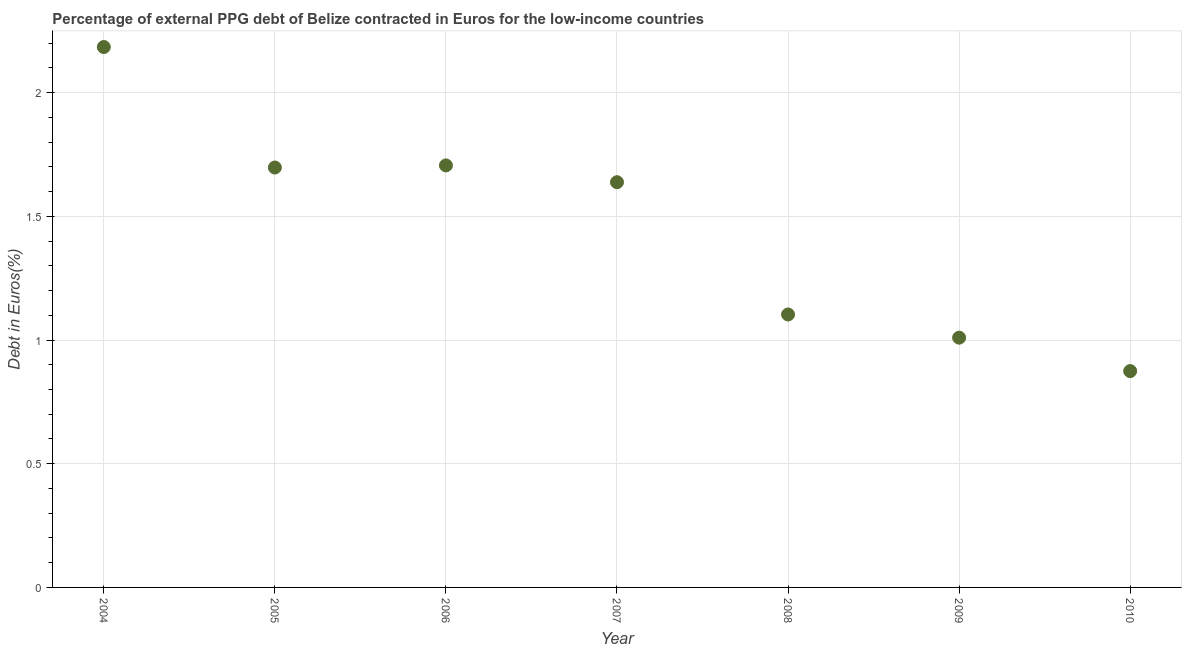What is the currency composition of ppg debt in 2009?
Give a very brief answer. 1.01. Across all years, what is the maximum currency composition of ppg debt?
Offer a very short reply. 2.18. Across all years, what is the minimum currency composition of ppg debt?
Provide a succinct answer. 0.87. What is the sum of the currency composition of ppg debt?
Make the answer very short. 10.21. What is the difference between the currency composition of ppg debt in 2004 and 2005?
Offer a very short reply. 0.49. What is the average currency composition of ppg debt per year?
Keep it short and to the point. 1.46. What is the median currency composition of ppg debt?
Offer a terse response. 1.64. In how many years, is the currency composition of ppg debt greater than 0.4 %?
Offer a terse response. 7. What is the ratio of the currency composition of ppg debt in 2006 to that in 2009?
Provide a short and direct response. 1.69. Is the difference between the currency composition of ppg debt in 2009 and 2010 greater than the difference between any two years?
Your response must be concise. No. What is the difference between the highest and the second highest currency composition of ppg debt?
Ensure brevity in your answer.  0.48. Is the sum of the currency composition of ppg debt in 2009 and 2010 greater than the maximum currency composition of ppg debt across all years?
Give a very brief answer. No. What is the difference between the highest and the lowest currency composition of ppg debt?
Offer a terse response. 1.31. In how many years, is the currency composition of ppg debt greater than the average currency composition of ppg debt taken over all years?
Offer a terse response. 4. How many years are there in the graph?
Your response must be concise. 7. What is the difference between two consecutive major ticks on the Y-axis?
Ensure brevity in your answer.  0.5. Are the values on the major ticks of Y-axis written in scientific E-notation?
Provide a short and direct response. No. Does the graph contain grids?
Your response must be concise. Yes. What is the title of the graph?
Keep it short and to the point. Percentage of external PPG debt of Belize contracted in Euros for the low-income countries. What is the label or title of the X-axis?
Keep it short and to the point. Year. What is the label or title of the Y-axis?
Make the answer very short. Debt in Euros(%). What is the Debt in Euros(%) in 2004?
Make the answer very short. 2.18. What is the Debt in Euros(%) in 2005?
Offer a very short reply. 1.7. What is the Debt in Euros(%) in 2006?
Ensure brevity in your answer.  1.71. What is the Debt in Euros(%) in 2007?
Ensure brevity in your answer.  1.64. What is the Debt in Euros(%) in 2008?
Keep it short and to the point. 1.1. What is the Debt in Euros(%) in 2009?
Offer a very short reply. 1.01. What is the Debt in Euros(%) in 2010?
Offer a very short reply. 0.87. What is the difference between the Debt in Euros(%) in 2004 and 2005?
Provide a short and direct response. 0.49. What is the difference between the Debt in Euros(%) in 2004 and 2006?
Offer a terse response. 0.48. What is the difference between the Debt in Euros(%) in 2004 and 2007?
Offer a very short reply. 0.55. What is the difference between the Debt in Euros(%) in 2004 and 2008?
Offer a very short reply. 1.08. What is the difference between the Debt in Euros(%) in 2004 and 2009?
Your answer should be compact. 1.17. What is the difference between the Debt in Euros(%) in 2004 and 2010?
Your response must be concise. 1.31. What is the difference between the Debt in Euros(%) in 2005 and 2006?
Keep it short and to the point. -0.01. What is the difference between the Debt in Euros(%) in 2005 and 2007?
Provide a succinct answer. 0.06. What is the difference between the Debt in Euros(%) in 2005 and 2008?
Ensure brevity in your answer.  0.59. What is the difference between the Debt in Euros(%) in 2005 and 2009?
Offer a terse response. 0.69. What is the difference between the Debt in Euros(%) in 2005 and 2010?
Your answer should be compact. 0.82. What is the difference between the Debt in Euros(%) in 2006 and 2007?
Your response must be concise. 0.07. What is the difference between the Debt in Euros(%) in 2006 and 2008?
Provide a succinct answer. 0.6. What is the difference between the Debt in Euros(%) in 2006 and 2009?
Keep it short and to the point. 0.7. What is the difference between the Debt in Euros(%) in 2006 and 2010?
Ensure brevity in your answer.  0.83. What is the difference between the Debt in Euros(%) in 2007 and 2008?
Your response must be concise. 0.53. What is the difference between the Debt in Euros(%) in 2007 and 2009?
Provide a succinct answer. 0.63. What is the difference between the Debt in Euros(%) in 2007 and 2010?
Give a very brief answer. 0.76. What is the difference between the Debt in Euros(%) in 2008 and 2009?
Offer a very short reply. 0.09. What is the difference between the Debt in Euros(%) in 2008 and 2010?
Ensure brevity in your answer.  0.23. What is the difference between the Debt in Euros(%) in 2009 and 2010?
Ensure brevity in your answer.  0.14. What is the ratio of the Debt in Euros(%) in 2004 to that in 2005?
Your answer should be very brief. 1.29. What is the ratio of the Debt in Euros(%) in 2004 to that in 2006?
Keep it short and to the point. 1.28. What is the ratio of the Debt in Euros(%) in 2004 to that in 2007?
Provide a short and direct response. 1.33. What is the ratio of the Debt in Euros(%) in 2004 to that in 2008?
Offer a terse response. 1.98. What is the ratio of the Debt in Euros(%) in 2004 to that in 2009?
Your answer should be compact. 2.16. What is the ratio of the Debt in Euros(%) in 2004 to that in 2010?
Offer a very short reply. 2.5. What is the ratio of the Debt in Euros(%) in 2005 to that in 2006?
Your response must be concise. 0.99. What is the ratio of the Debt in Euros(%) in 2005 to that in 2007?
Make the answer very short. 1.04. What is the ratio of the Debt in Euros(%) in 2005 to that in 2008?
Ensure brevity in your answer.  1.54. What is the ratio of the Debt in Euros(%) in 2005 to that in 2009?
Give a very brief answer. 1.68. What is the ratio of the Debt in Euros(%) in 2005 to that in 2010?
Give a very brief answer. 1.94. What is the ratio of the Debt in Euros(%) in 2006 to that in 2007?
Provide a short and direct response. 1.04. What is the ratio of the Debt in Euros(%) in 2006 to that in 2008?
Give a very brief answer. 1.55. What is the ratio of the Debt in Euros(%) in 2006 to that in 2009?
Your answer should be compact. 1.69. What is the ratio of the Debt in Euros(%) in 2006 to that in 2010?
Give a very brief answer. 1.95. What is the ratio of the Debt in Euros(%) in 2007 to that in 2008?
Your answer should be compact. 1.49. What is the ratio of the Debt in Euros(%) in 2007 to that in 2009?
Provide a short and direct response. 1.62. What is the ratio of the Debt in Euros(%) in 2007 to that in 2010?
Keep it short and to the point. 1.87. What is the ratio of the Debt in Euros(%) in 2008 to that in 2009?
Your answer should be compact. 1.09. What is the ratio of the Debt in Euros(%) in 2008 to that in 2010?
Your response must be concise. 1.26. What is the ratio of the Debt in Euros(%) in 2009 to that in 2010?
Provide a succinct answer. 1.16. 